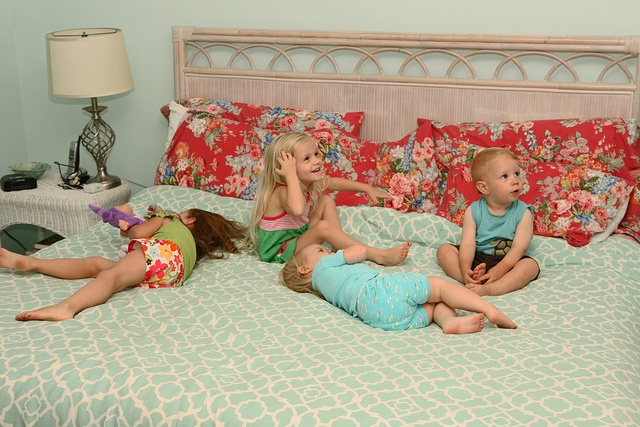Describe the objects in this image and their specific colors. I can see bed in darkgray, beige, and tan tones, people in darkgray, turquoise, and tan tones, people in darkgray, tan, and gray tones, people in darkgray, tan, salmon, and maroon tones, and people in darkgray, tan, salmon, and teal tones in this image. 